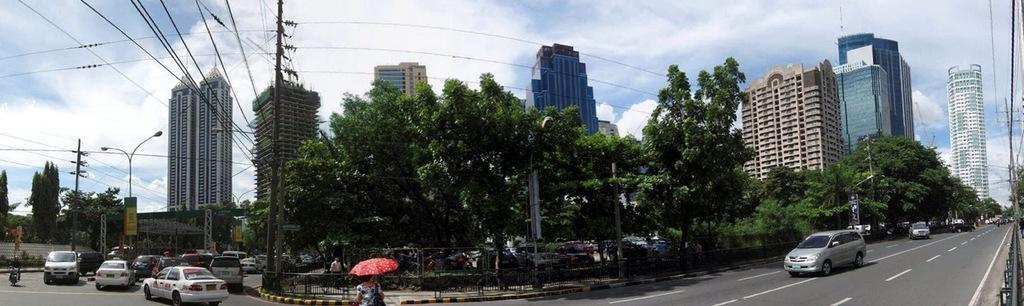Describe this image in one or two sentences. This is the picture of a city. In this image there are vehicles on the road. In the middle of the image there is a woman holding the umbrella and there is a person walking on the footpath behind the railing. At the back there are buildings, trees and there are wires on the poles and there are street lights. At the top there is sky and there are clouds. At the bottom there is a road. On the right side the image there is a railing. On the left side of the image there is a person riding motorbike. 